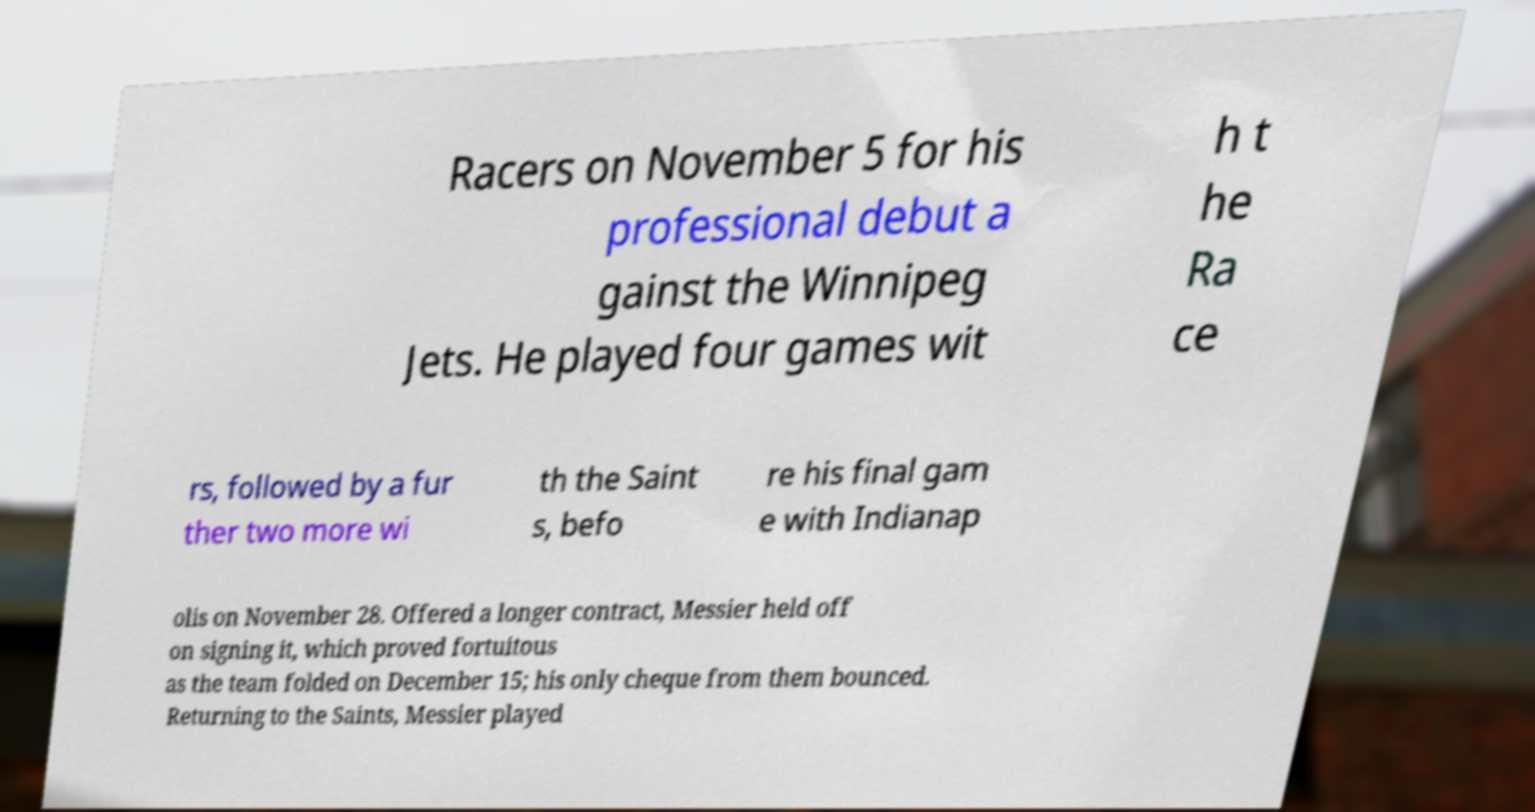Can you accurately transcribe the text from the provided image for me? Racers on November 5 for his professional debut a gainst the Winnipeg Jets. He played four games wit h t he Ra ce rs, followed by a fur ther two more wi th the Saint s, befo re his final gam e with Indianap olis on November 28. Offered a longer contract, Messier held off on signing it, which proved fortuitous as the team folded on December 15; his only cheque from them bounced. Returning to the Saints, Messier played 